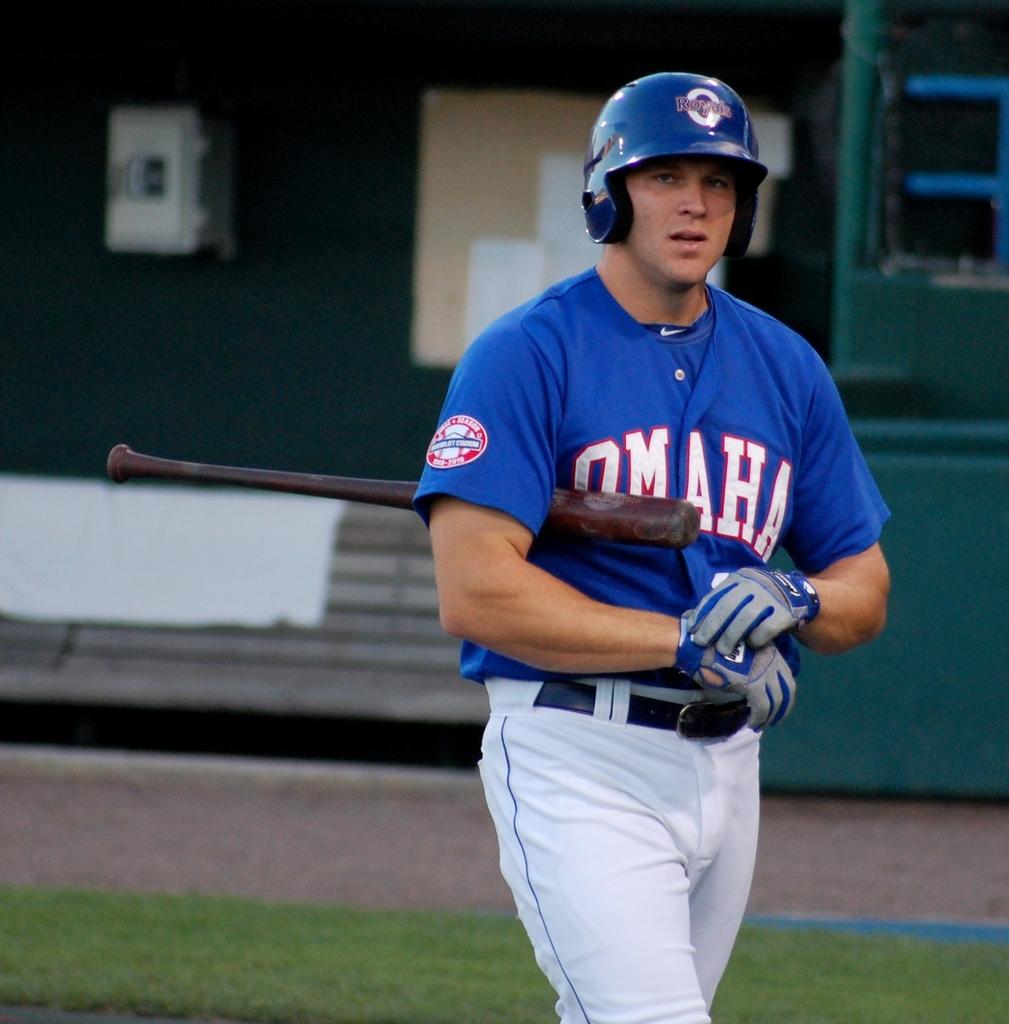What team does he play on?
Ensure brevity in your answer.  Omaha. What color is the team name on the player jersey?
Offer a very short reply. White. 